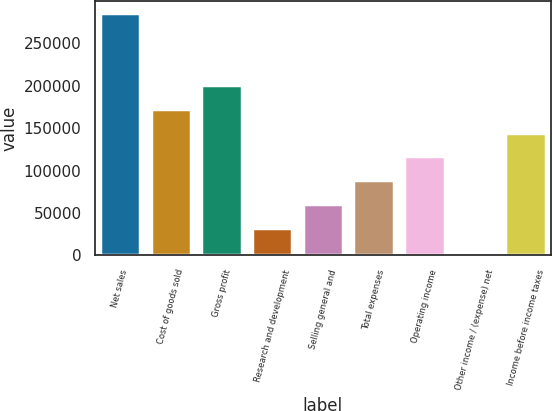<chart> <loc_0><loc_0><loc_500><loc_500><bar_chart><fcel>Net sales<fcel>Cost of goods sold<fcel>Gross profit<fcel>Research and development<fcel>Selling general and<fcel>Total expenses<fcel>Operating income<fcel>Other income / (expense) net<fcel>Income before income taxes<nl><fcel>285362<fcel>173009<fcel>201132<fcel>32262.2<fcel>60384.4<fcel>88506.6<fcel>116765<fcel>4140<fcel>144887<nl></chart> 